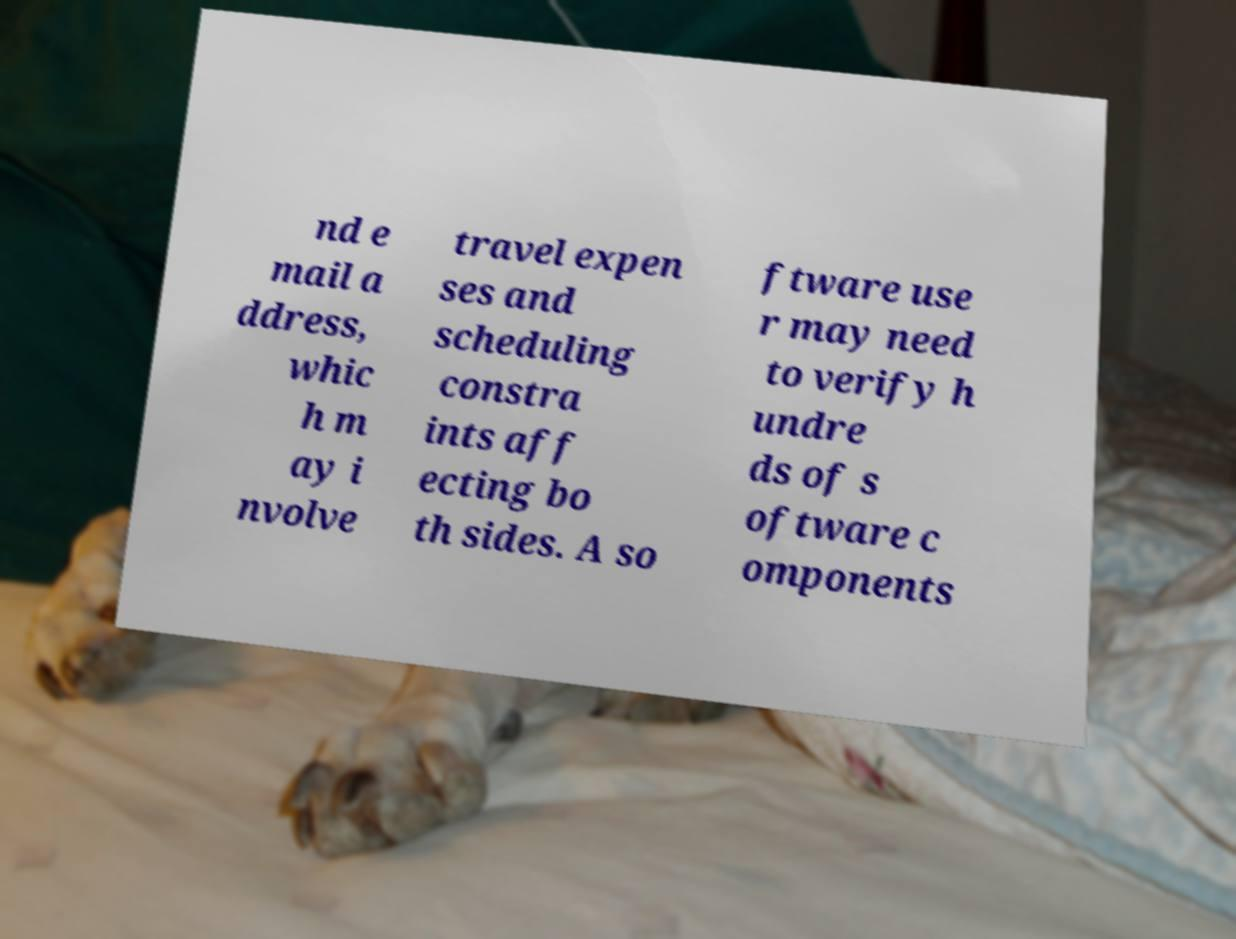Please read and relay the text visible in this image. What does it say? nd e mail a ddress, whic h m ay i nvolve travel expen ses and scheduling constra ints aff ecting bo th sides. A so ftware use r may need to verify h undre ds of s oftware c omponents 